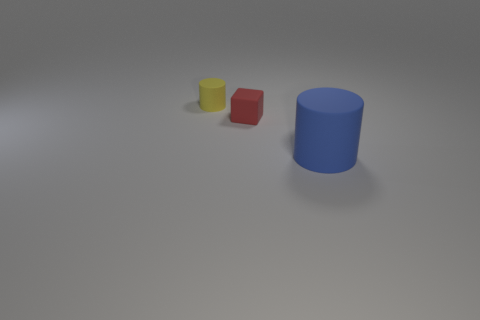There is a thing that is both behind the large blue rubber cylinder and right of the yellow matte cylinder; what is its material?
Your answer should be compact. Rubber. What number of other things are the same color as the small matte block?
Make the answer very short. 0. How many other big things are the same shape as the red rubber thing?
Give a very brief answer. 0. There is a cylinder that is made of the same material as the blue thing; what size is it?
Offer a very short reply. Small. Are there any blue rubber cylinders in front of the cylinder that is right of the tiny yellow cylinder left of the red thing?
Provide a short and direct response. No. There is a cylinder that is behind the blue rubber thing; is its size the same as the blue matte cylinder?
Provide a succinct answer. No. How many objects have the same size as the red block?
Make the answer very short. 1. Does the tiny rubber cylinder have the same color as the large object?
Offer a very short reply. No. What shape is the yellow object?
Your answer should be very brief. Cylinder. Are there any other matte objects that have the same color as the large matte object?
Your answer should be compact. No. 